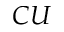Convert formula to latex. <formula><loc_0><loc_0><loc_500><loc_500>C U</formula> 